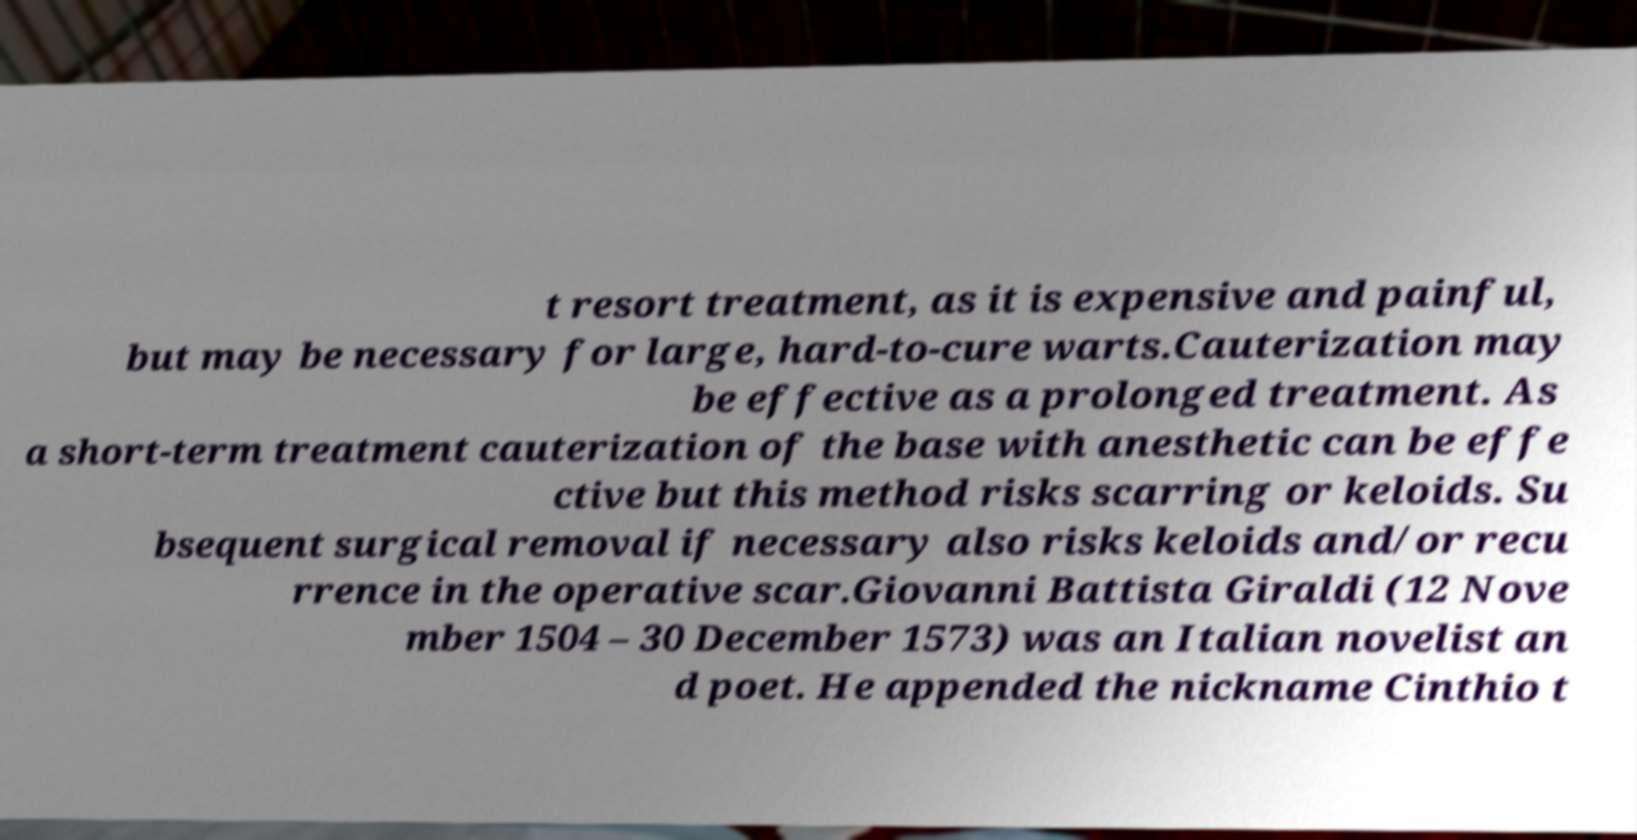Please read and relay the text visible in this image. What does it say? t resort treatment, as it is expensive and painful, but may be necessary for large, hard-to-cure warts.Cauterization may be effective as a prolonged treatment. As a short-term treatment cauterization of the base with anesthetic can be effe ctive but this method risks scarring or keloids. Su bsequent surgical removal if necessary also risks keloids and/or recu rrence in the operative scar.Giovanni Battista Giraldi (12 Nove mber 1504 – 30 December 1573) was an Italian novelist an d poet. He appended the nickname Cinthio t 